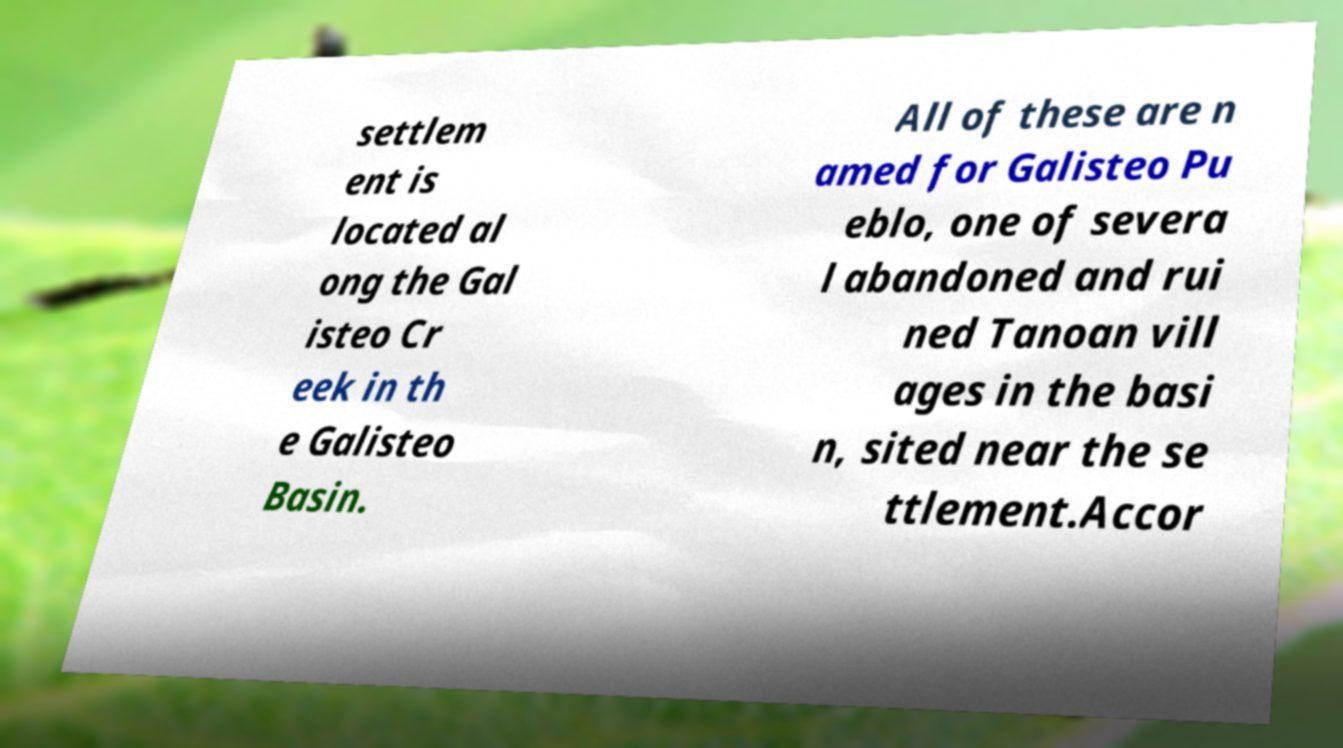For documentation purposes, I need the text within this image transcribed. Could you provide that? settlem ent is located al ong the Gal isteo Cr eek in th e Galisteo Basin. All of these are n amed for Galisteo Pu eblo, one of severa l abandoned and rui ned Tanoan vill ages in the basi n, sited near the se ttlement.Accor 